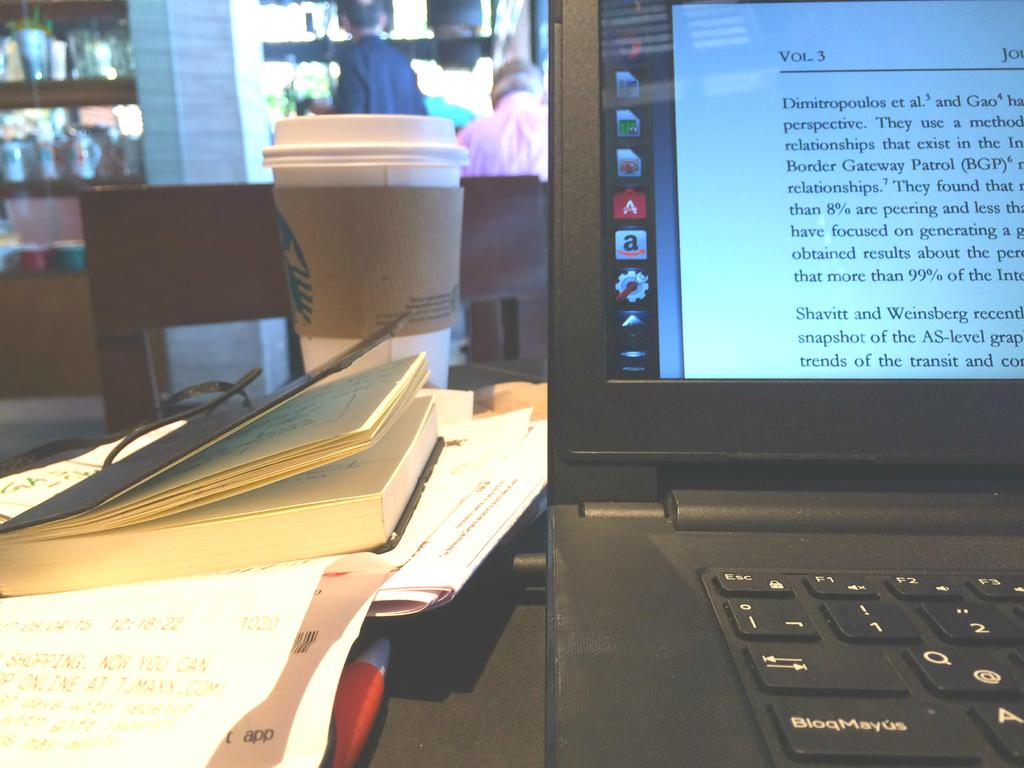<image>
Describe the image concisely. A laptop computer open to a page on Border Gateway Patrol (BGP) is sitting open on a desk next to notebooks 